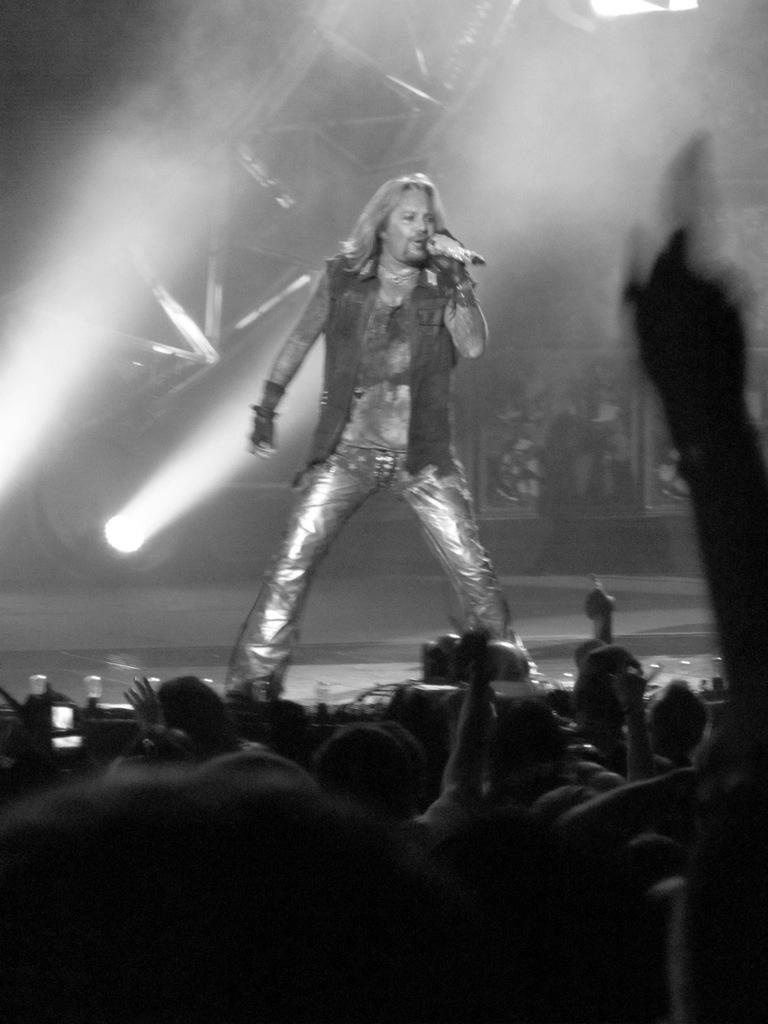What is the color scheme of the image? The image is black and white. What event or activity is depicted in the image? The image appears to depict a musical concert. Where are the people located in the image? There are people at the bottom of the image. What is the person in the middle of the image doing? The person in the middle is holding a microphone. How does the ink flow in the image? There is no ink present in the image, as it is a black and white photograph of a musical concert. 